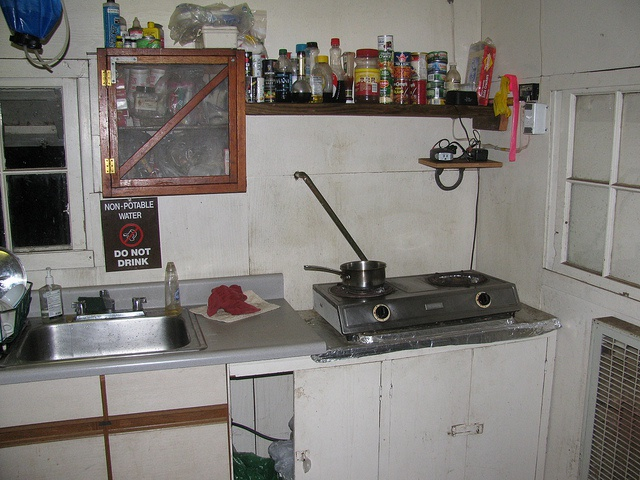Describe the objects in this image and their specific colors. I can see sink in black, darkgray, lightgray, and gray tones, bowl in black, gray, darkgray, and white tones, bottle in black, gray, and darkgray tones, bottle in black, gray, and darkgray tones, and bottle in black, gray, darkgreen, and blue tones in this image. 